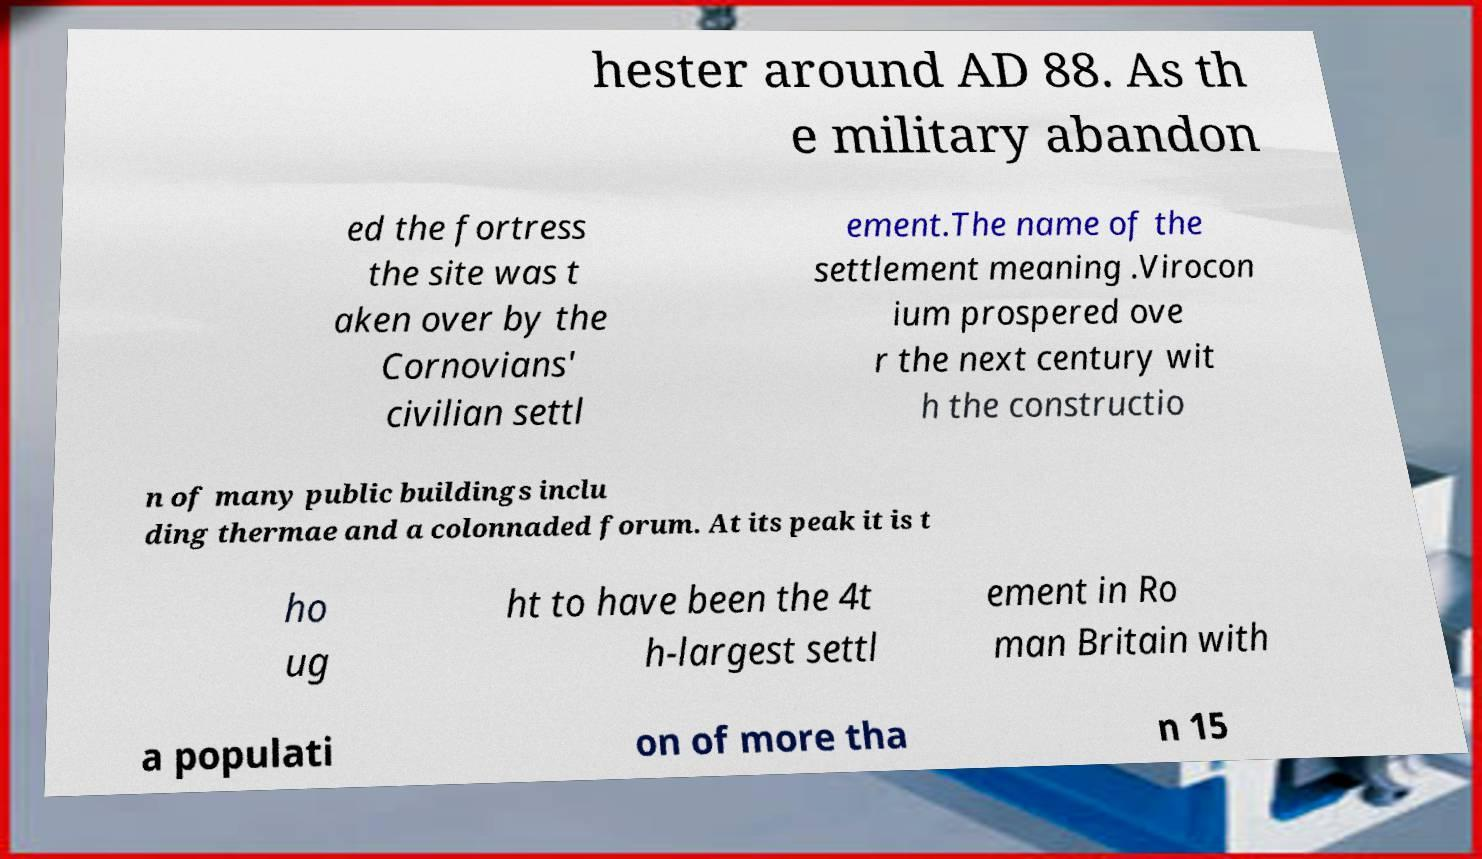There's text embedded in this image that I need extracted. Can you transcribe it verbatim? hester around AD 88. As th e military abandon ed the fortress the site was t aken over by the Cornovians' civilian settl ement.The name of the settlement meaning .Virocon ium prospered ove r the next century wit h the constructio n of many public buildings inclu ding thermae and a colonnaded forum. At its peak it is t ho ug ht to have been the 4t h-largest settl ement in Ro man Britain with a populati on of more tha n 15 